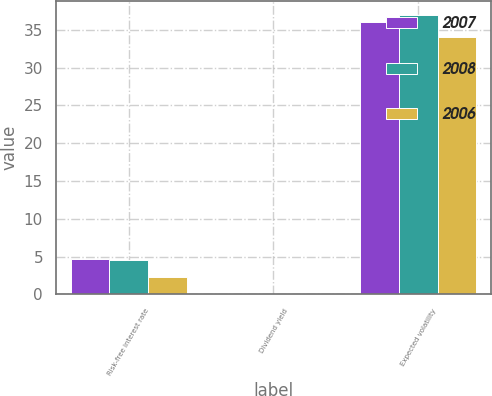<chart> <loc_0><loc_0><loc_500><loc_500><stacked_bar_chart><ecel><fcel>Risk-free interest rate<fcel>Dividend yield<fcel>Expected volatility<nl><fcel>2007<fcel>4.7<fcel>0<fcel>36<nl><fcel>2008<fcel>4.5<fcel>0<fcel>37<nl><fcel>2006<fcel>2.3<fcel>0<fcel>34<nl></chart> 